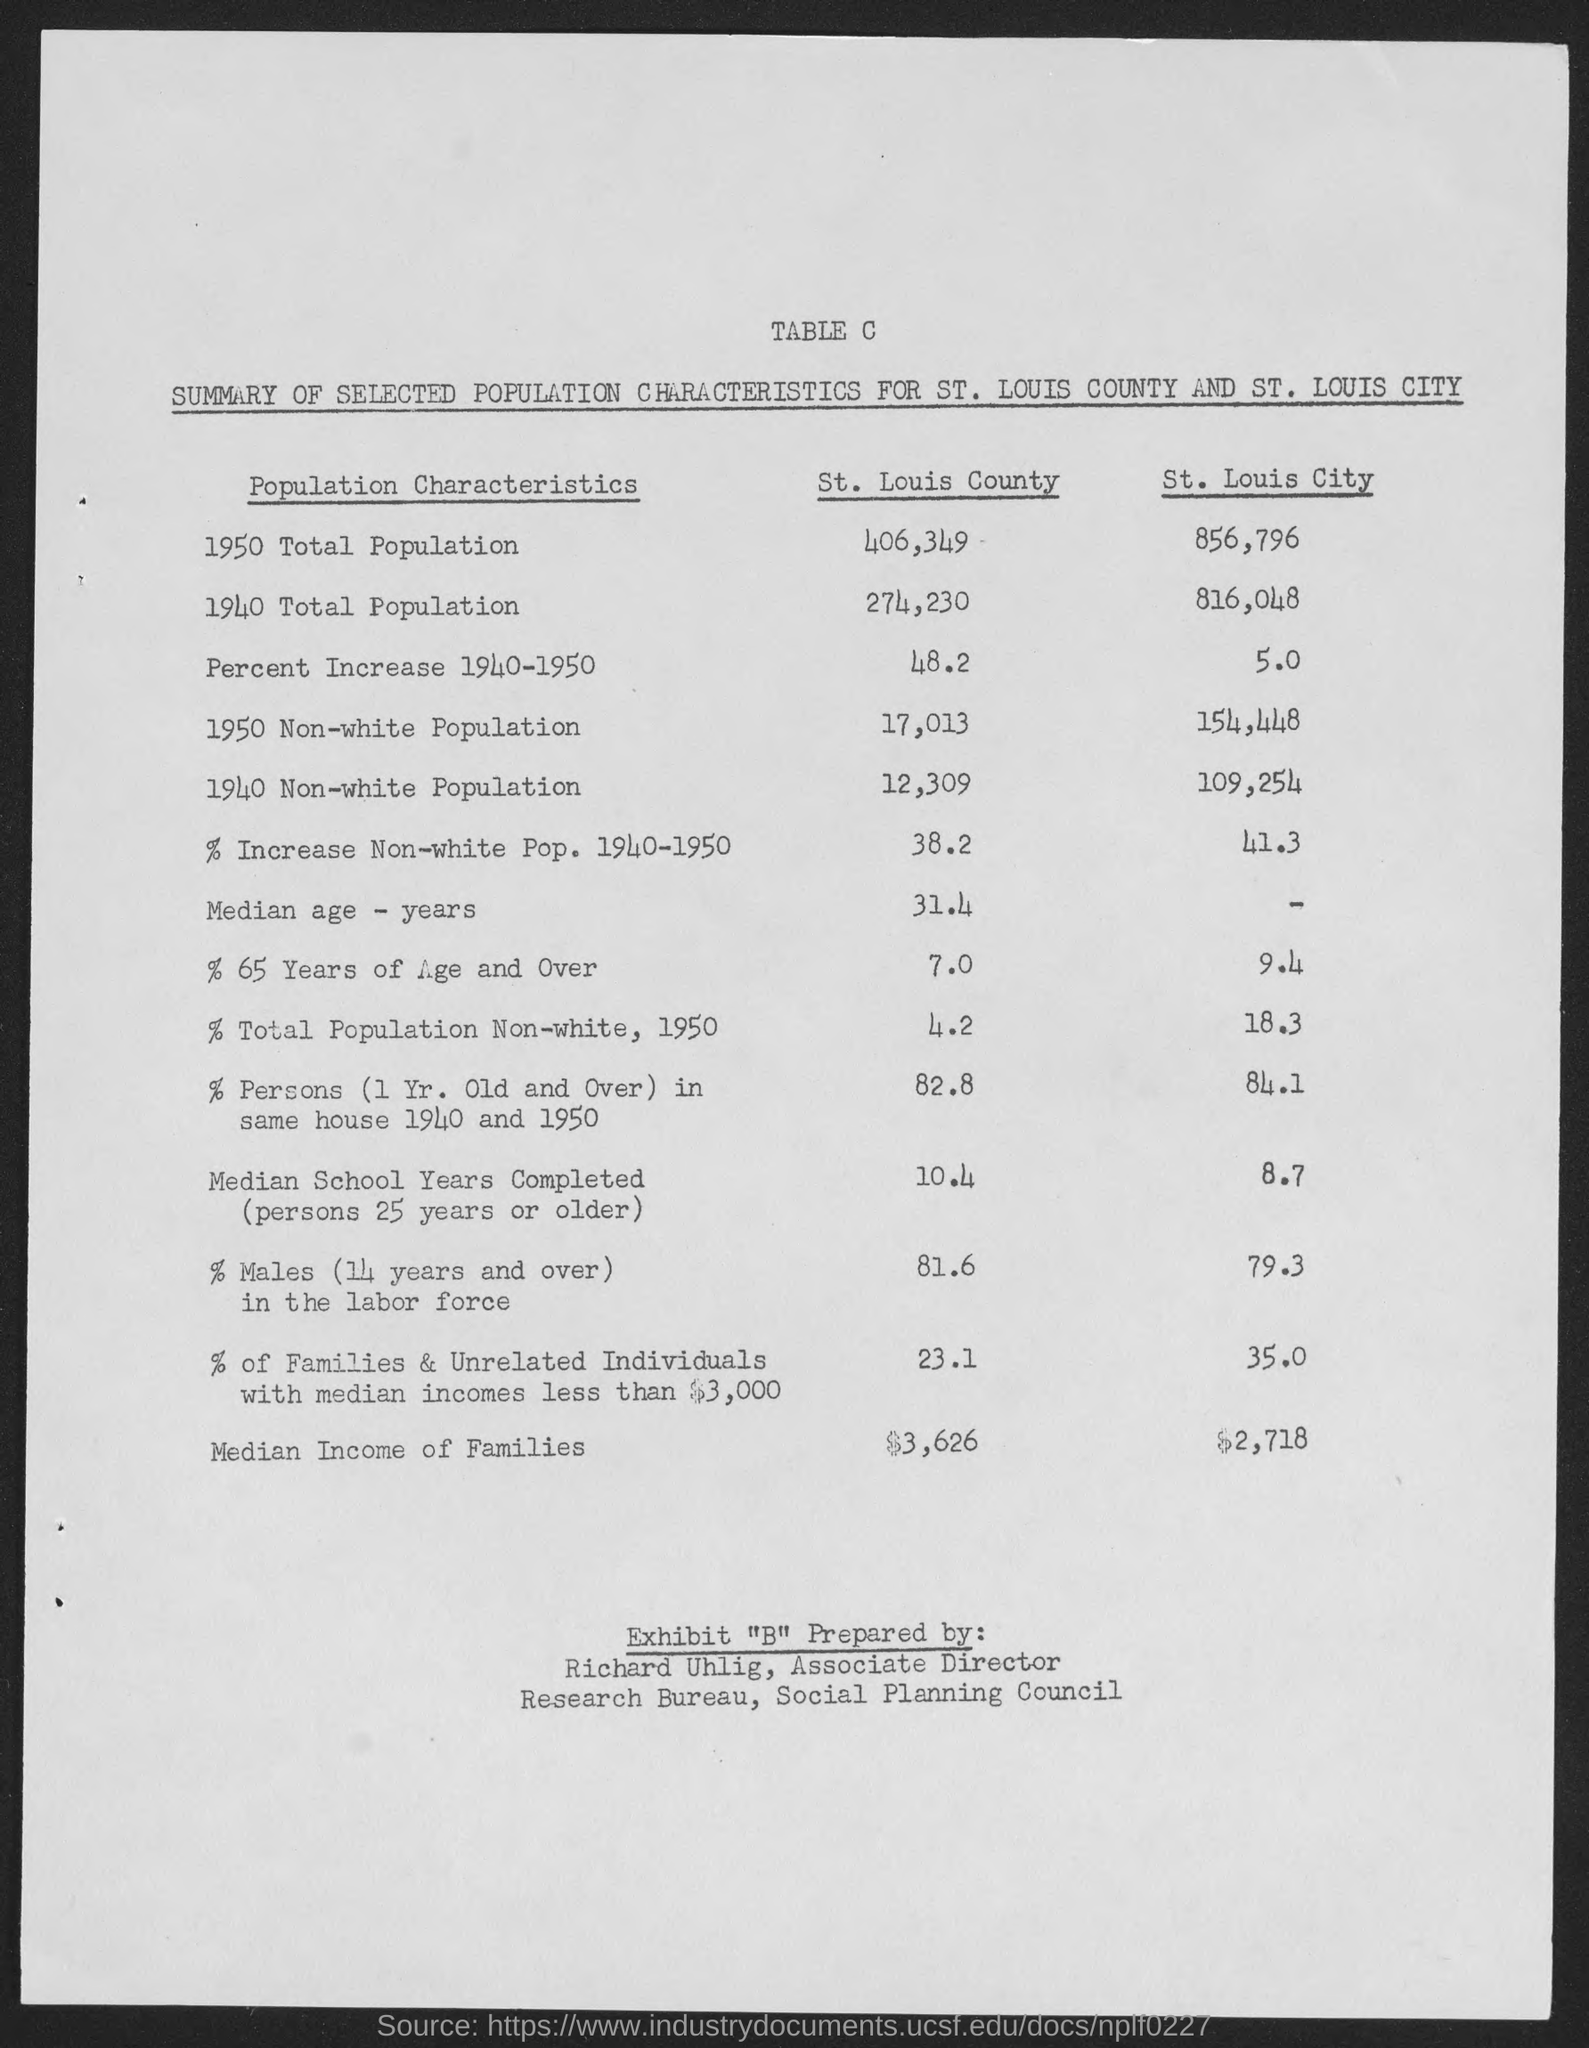What is the total population of St. Louis County in 1950?
Make the answer very short. 406,349. What is the total population of St. Louis City in 1940?
Offer a very short reply. 816,048. What is the percent increase of population in St. Louis County during the year 1940-1950?
Provide a short and direct response. 48.2. What is the non-white population of St. Louis County in the year 1950?
Your response must be concise. 17,013. What is the non-white population of St. Louis City in the year 1940?
Offer a terse response. 109,254. What is the median income of families in St. Louis county?
Ensure brevity in your answer.  $3,626. What is the median income of families in St. Louis city?
Offer a terse response. $2,718. Who prepared Exhibit 'B" as per the document?
Provide a short and direct response. Richard Uhlig, Associate Director. 